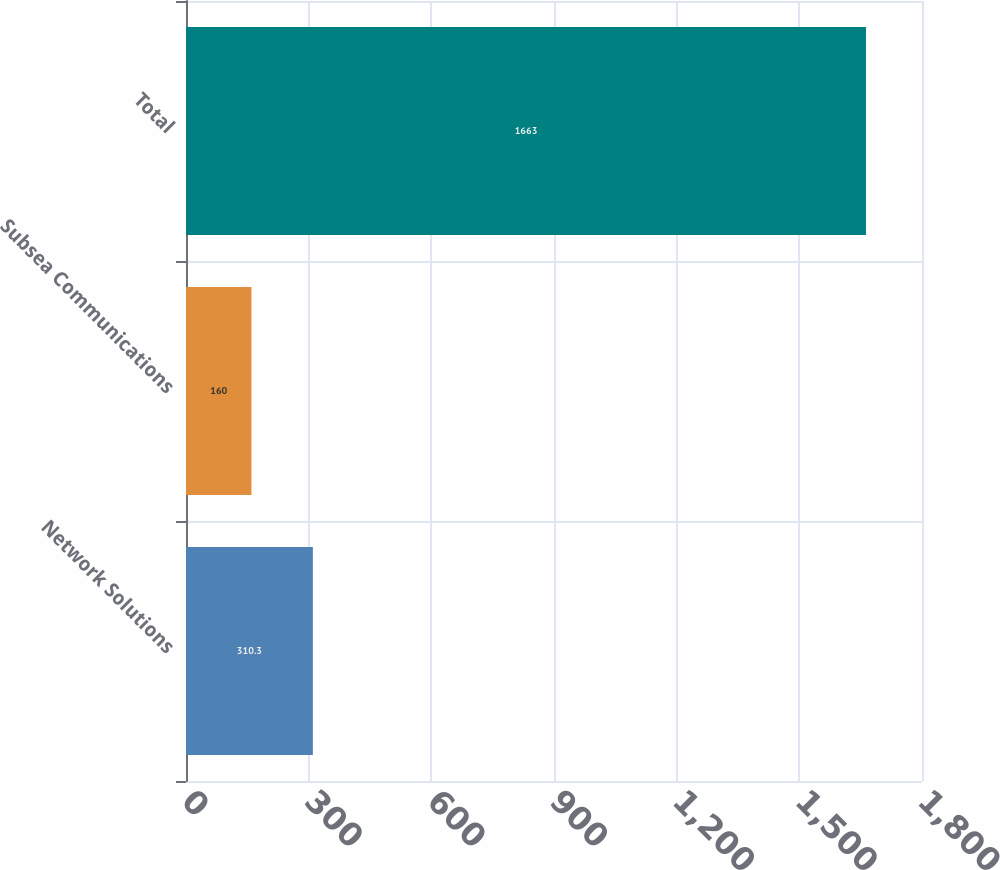<chart> <loc_0><loc_0><loc_500><loc_500><bar_chart><fcel>Network Solutions<fcel>Subsea Communications<fcel>Total<nl><fcel>310.3<fcel>160<fcel>1663<nl></chart> 